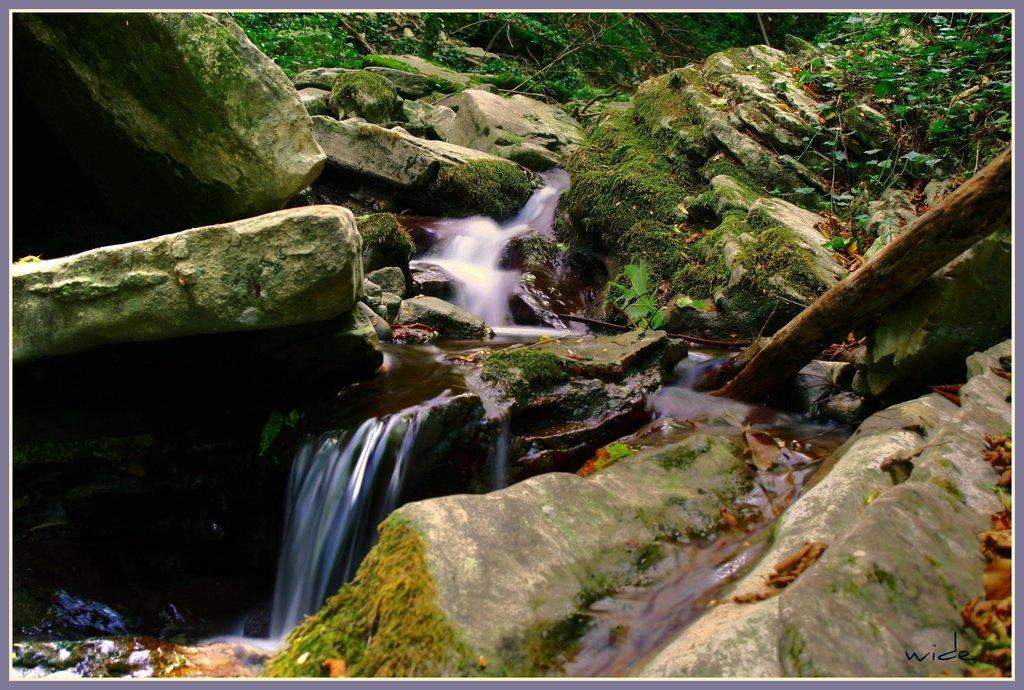Please provide a concise description of this image. In this image, we can see the waterfall. We can see some rocks, plants. We can also see some grass and a wooden pole. We can also see some text on the bottom right corner. 